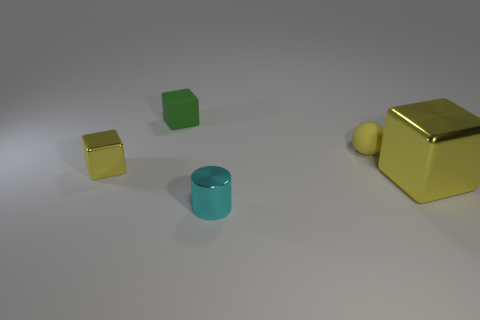Subtract all large metallic blocks. How many blocks are left? 2 Add 1 large green metallic blocks. How many objects exist? 6 Subtract all cubes. How many objects are left? 2 Subtract 2 blocks. How many blocks are left? 1 Subtract all yellow blocks. How many blocks are left? 1 Subtract all yellow balls. How many green cylinders are left? 0 Add 2 small cubes. How many small cubes are left? 4 Add 5 small yellow cubes. How many small yellow cubes exist? 6 Subtract 0 purple cylinders. How many objects are left? 5 Subtract all gray cubes. Subtract all cyan cylinders. How many cubes are left? 3 